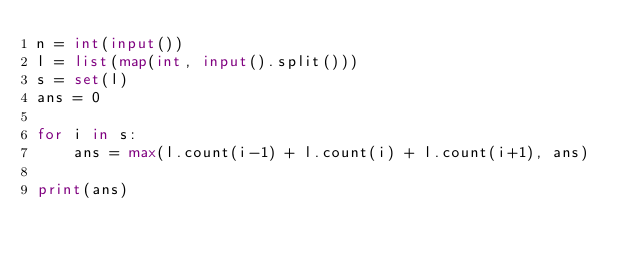<code> <loc_0><loc_0><loc_500><loc_500><_Python_>n = int(input())
l = list(map(int, input().split()))
s = set(l)
ans = 0

for i in s:
    ans = max(l.count(i-1) + l.count(i) + l.count(i+1), ans)

print(ans)</code> 